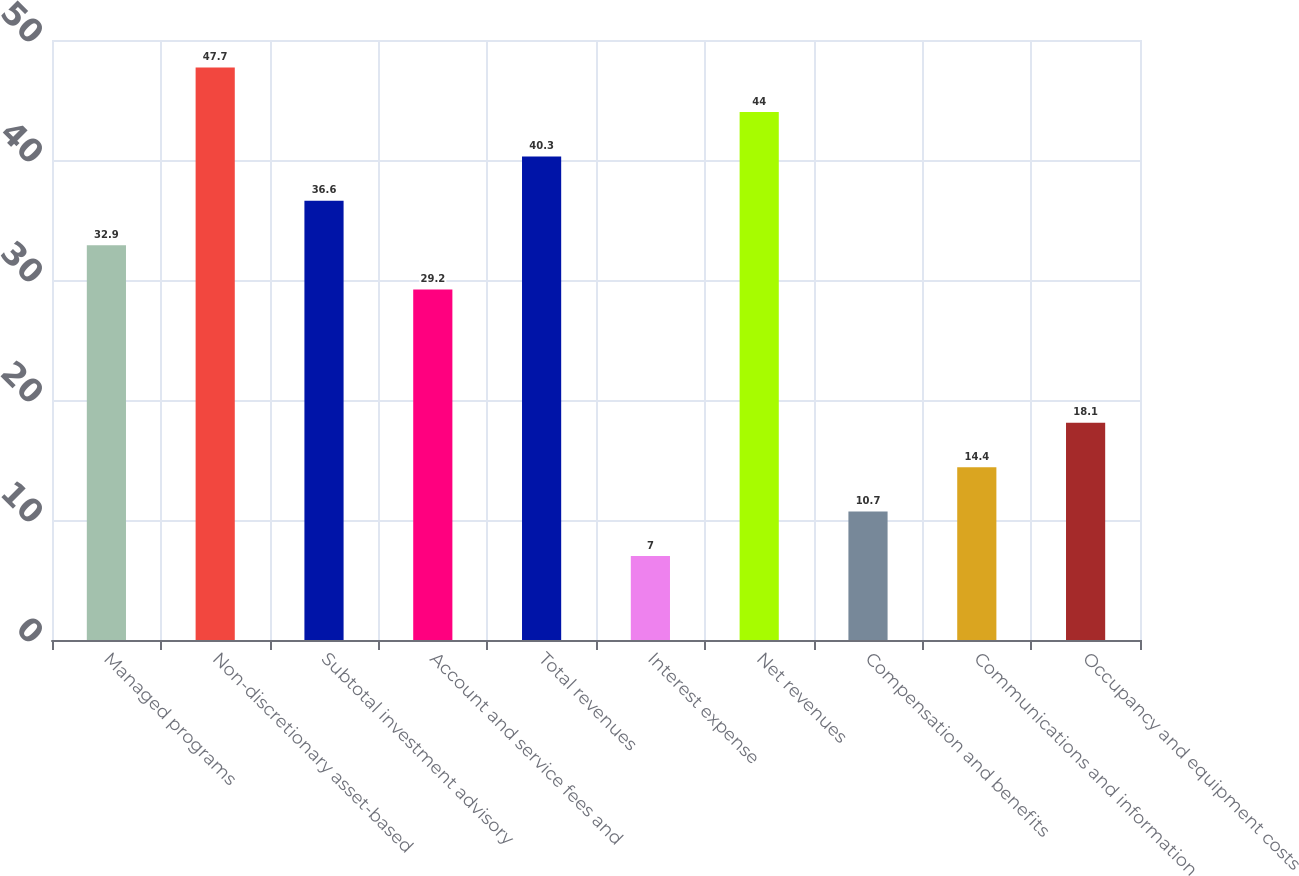Convert chart. <chart><loc_0><loc_0><loc_500><loc_500><bar_chart><fcel>Managed programs<fcel>Non-discretionary asset-based<fcel>Subtotal investment advisory<fcel>Account and service fees and<fcel>Total revenues<fcel>Interest expense<fcel>Net revenues<fcel>Compensation and benefits<fcel>Communications and information<fcel>Occupancy and equipment costs<nl><fcel>32.9<fcel>47.7<fcel>36.6<fcel>29.2<fcel>40.3<fcel>7<fcel>44<fcel>10.7<fcel>14.4<fcel>18.1<nl></chart> 